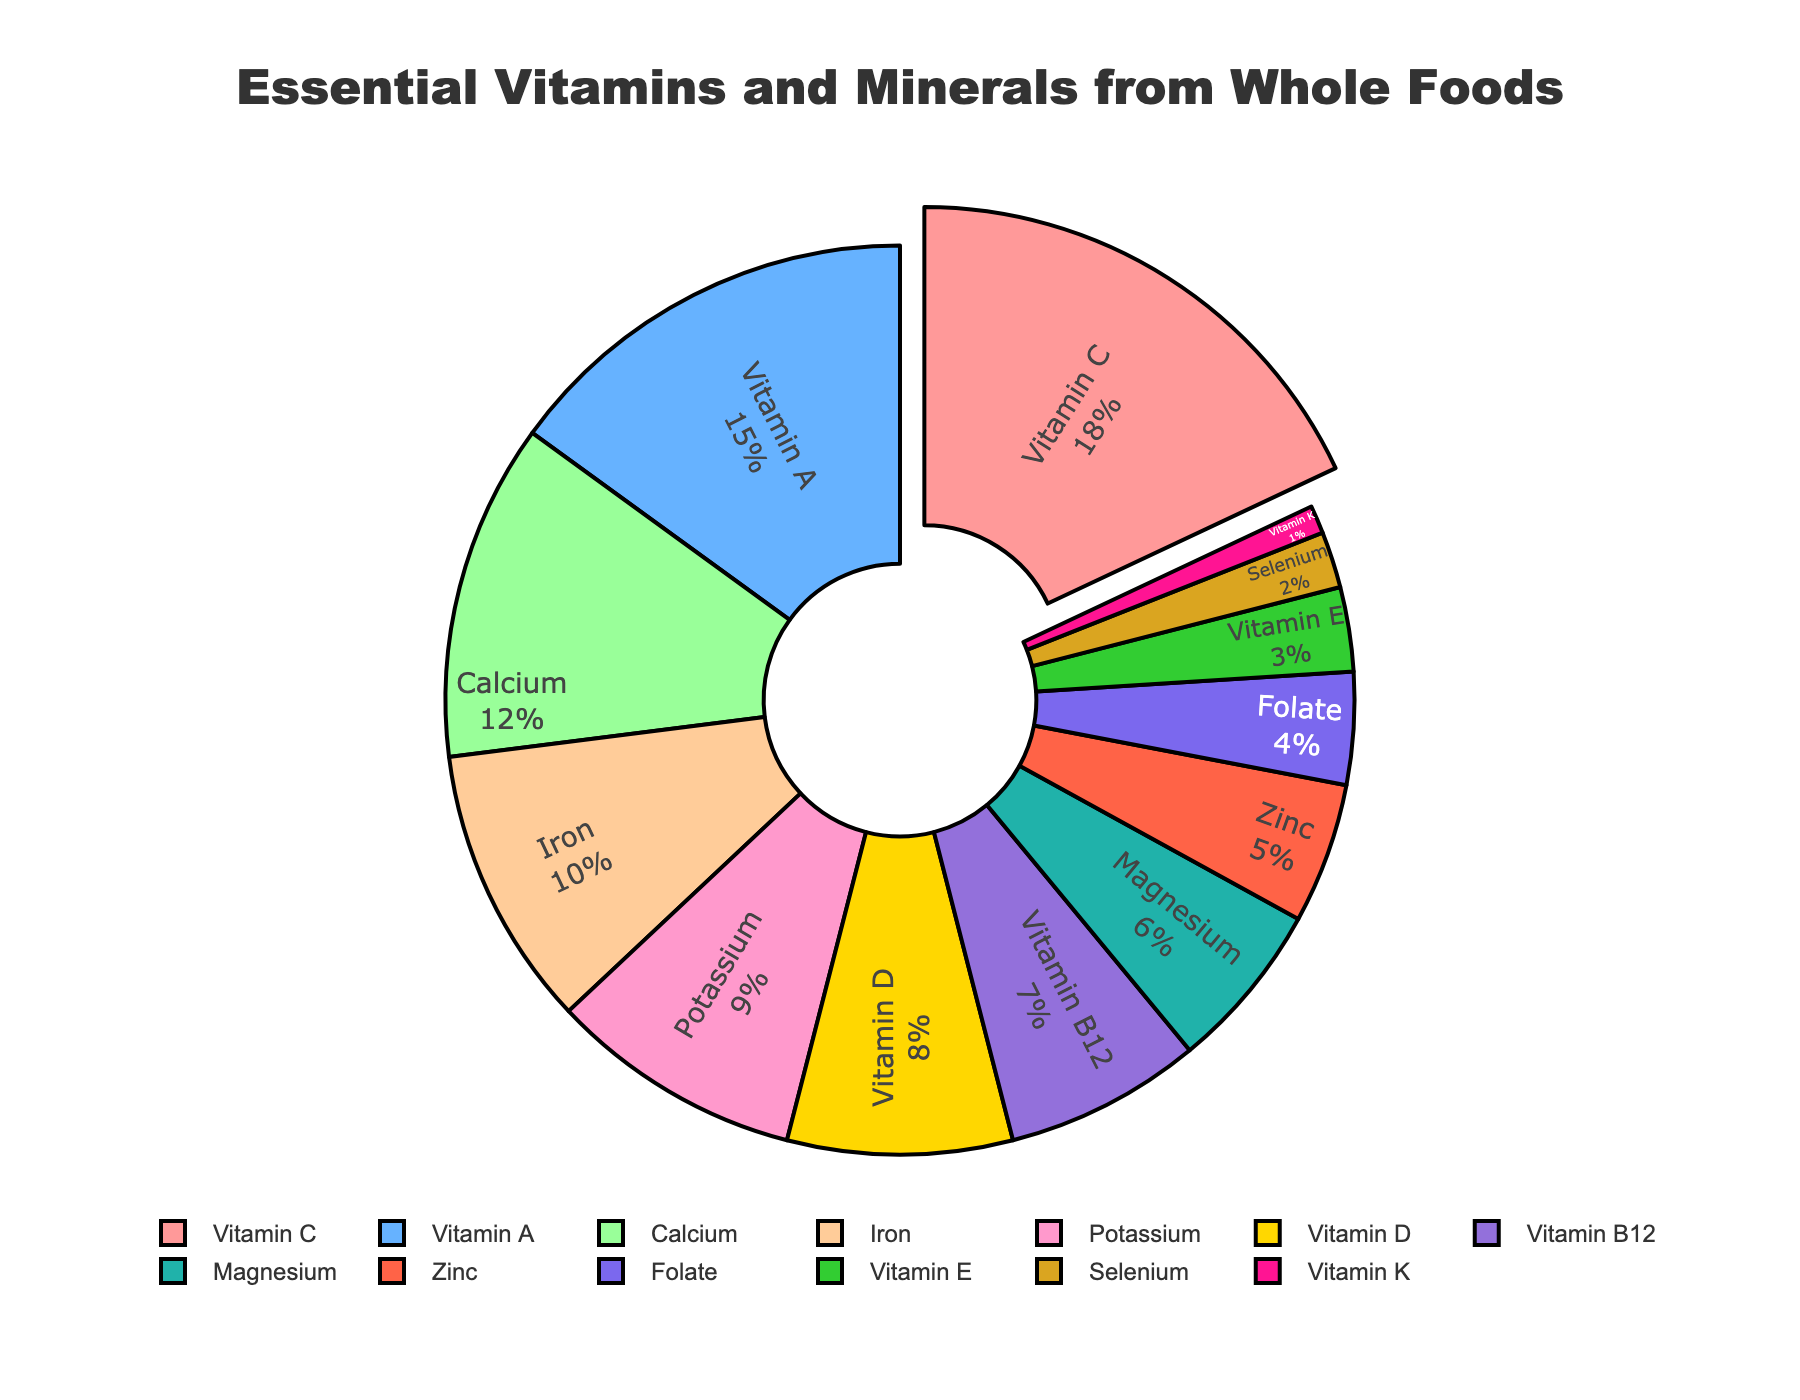What percentage of essential vitamins and minerals from whole foods does Vitamin A represent? The pie chart shows the percentage assigned to each vitamin and mineral. Vitamin A is represented as having 15%.
Answer: 15% Which vitamin or mineral is the smallest segment in the pie chart, and what is its percentage? The smallest segment in the pie chart is Vitamin K, which has a percentage of 1%.
Answer: Vitamin K, 1% How does the share of Vitamin D compare to that of Iron? Based on the pie chart, Vitamin D has a share of 8%, whereas Iron has a share of 10%. Therefore, Iron has a larger share than Vitamin D.
Answer: Iron has a larger share What is the combined percentage of Potassium and Magnesium? The pie chart indicates that Potassium is 9% and Magnesium is 6%. Adding these together gives 9% + 6% = 15%.
Answer: 15% Which vitamin or mineral has the largest segment, and how much larger is it compared to Vitamin B12? Vitamin C has the largest segment with 18%. Vitamin B12 has a segment of 7%. The difference is 18% - 7% = 11%.
Answer: Vitamin C is 11% larger than Vitamin B12 What is the sum of the percentages for Vitamin K, Selenium, and Folate? Vitamin K is 1%, Selenium is 2%, and Folate is 4%. Adding these together gives 1% + 2% + 4% = 7%.
Answer: 7% How many vitamins and minerals have a percentage below 5%? Looking at the pie chart, Folate (4%), Vitamin E (3%), Selenium (2%), and Vitamin K (1%) all have percentages below 5%. There are 4 in total.
Answer: 4 What color represents Calcium in the pie chart? The pie chart uses color coding, and Calcium is represented by an orange shade.
Answer: Orange If combining the percentages for Vitamin B12 and Zinc, what would be their total contribution? The chart shows that Vitamin B12 has 7% and Zinc has 5%. Their combined contribution would be 7% + 5% = 12%.
Answer: 12% Which vitamins or minerals collectively make up more than half (50%) of the pie chart? To find the collective percentage that makes up more than half, we need to sum the largest percentages until we reach over 50%. Vitamin C (18%), Vitamin A (15%), Calcium (12%), and Iron (10%) add up to 18% + 15% + 12% + 10% = 55%. They collectively make up more than half.
Answer: Vitamin C, Vitamin A, Calcium, Iron 